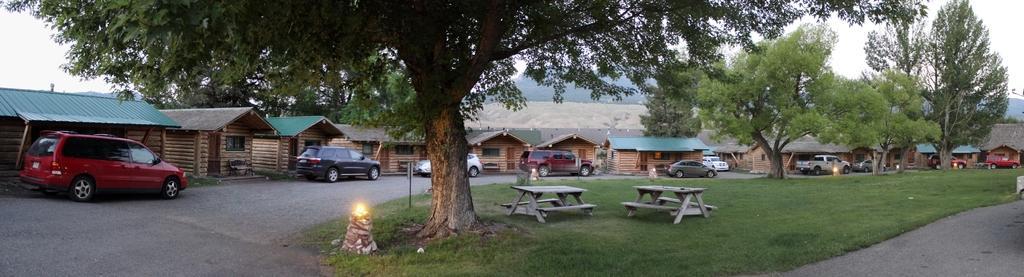Please provide a concise description of this image. In this picture we can see there are some vehicles on the road. In front of the vehicles, there are trees, a pole and there are picnic tables on the grass. Behind the vehicles there are houses, hills and the sky. There is light on an object. 